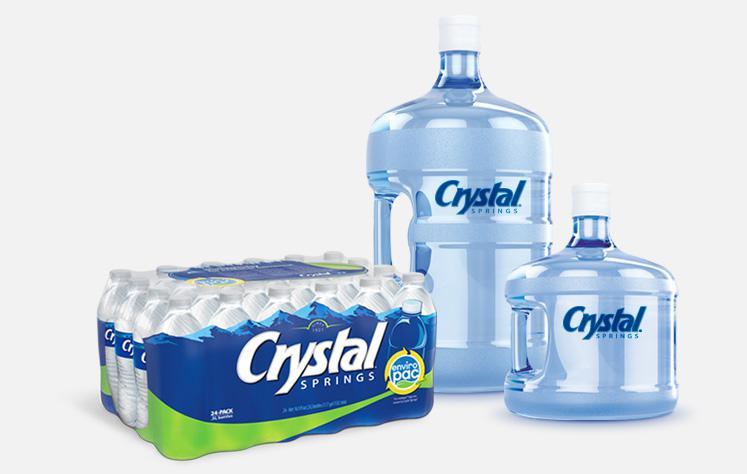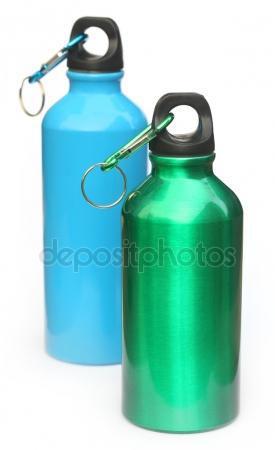The first image is the image on the left, the second image is the image on the right. For the images shown, is this caption "Exactly four blue tinted plastic bottles are shown, two with a hand grip in the side of the bottle, and two with no grips." true? Answer yes or no. No. The first image is the image on the left, the second image is the image on the right. Examine the images to the left and right. Is the description "An image includes a smaller handled jug next to a larger water jug with handle visible." accurate? Answer yes or no. Yes. 